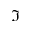<formula> <loc_0><loc_0><loc_500><loc_500>\Im</formula> 